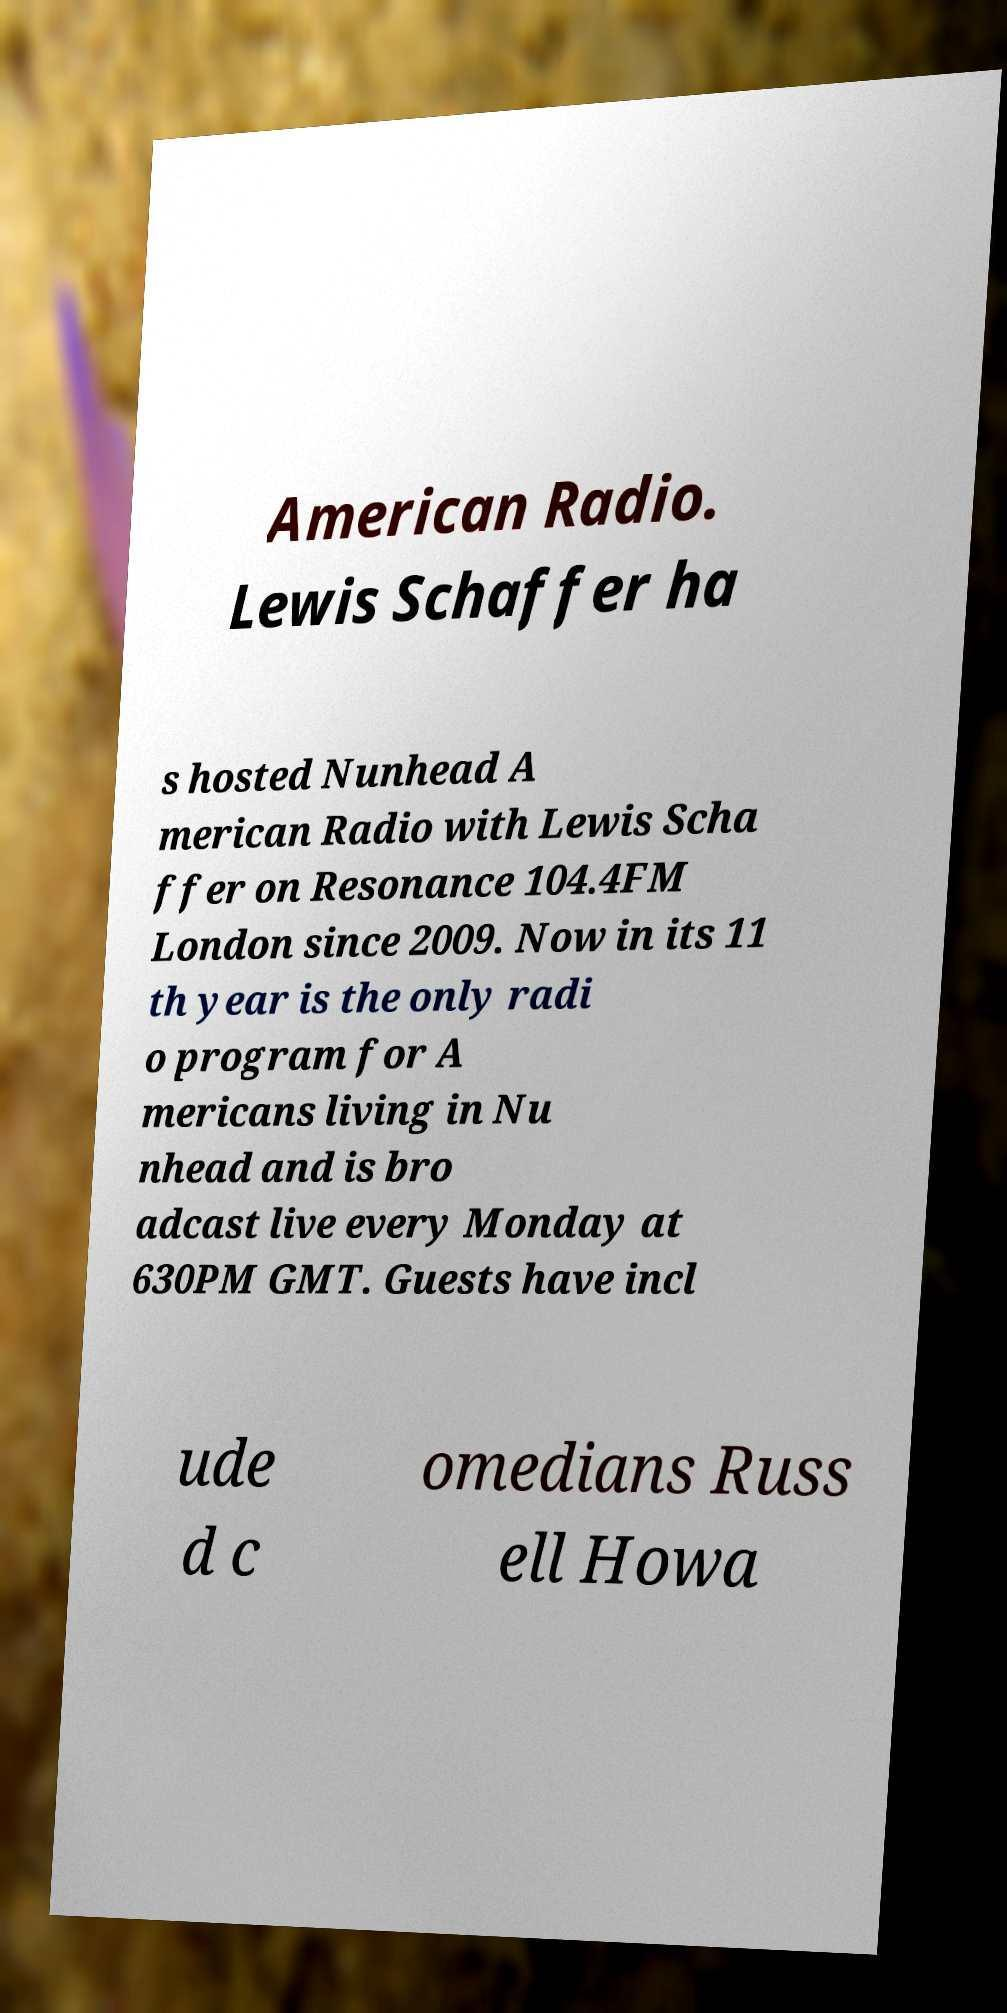Please read and relay the text visible in this image. What does it say? American Radio. Lewis Schaffer ha s hosted Nunhead A merican Radio with Lewis Scha ffer on Resonance 104.4FM London since 2009. Now in its 11 th year is the only radi o program for A mericans living in Nu nhead and is bro adcast live every Monday at 630PM GMT. Guests have incl ude d c omedians Russ ell Howa 